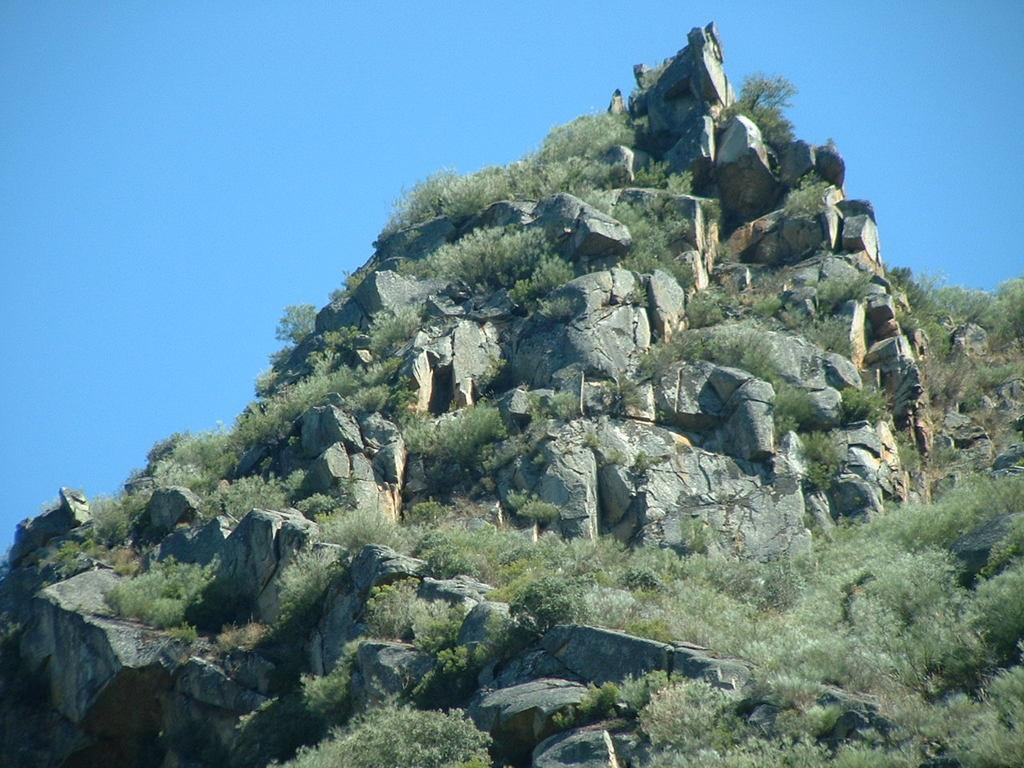What is the main feature in the image? There is a mountain in the image. What type of vegetation can be seen on the mountain? There is grass on the mountain. What can be seen in the background of the image? The sky is visible in the background of the image. What type of wool is being used to make the cars in the image? There are no cars present in the image, so there is no wool being used to make them. 